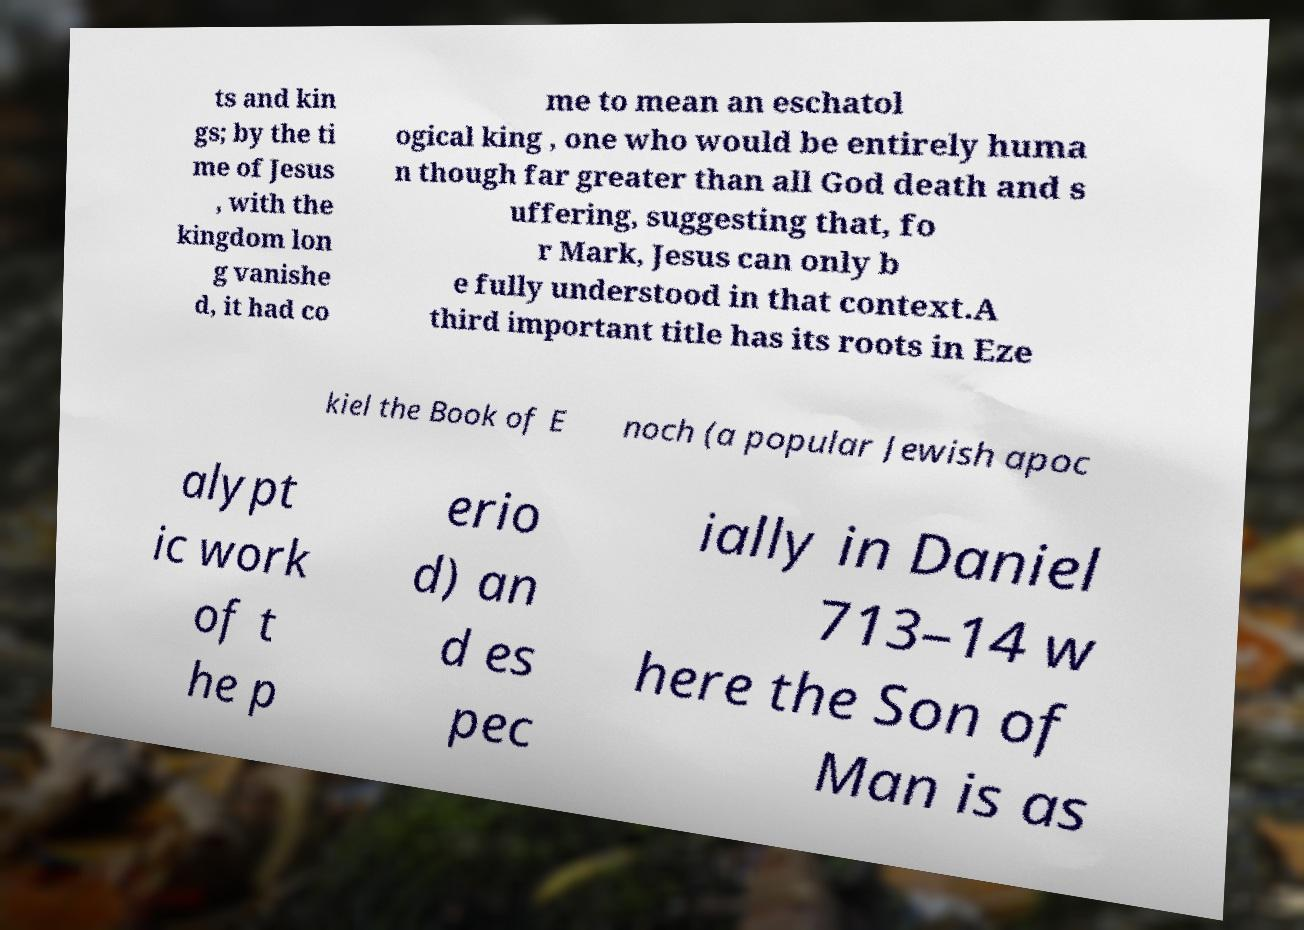Can you accurately transcribe the text from the provided image for me? ts and kin gs; by the ti me of Jesus , with the kingdom lon g vanishe d, it had co me to mean an eschatol ogical king , one who would be entirely huma n though far greater than all God death and s uffering, suggesting that, fo r Mark, Jesus can only b e fully understood in that context.A third important title has its roots in Eze kiel the Book of E noch (a popular Jewish apoc alypt ic work of t he p erio d) an d es pec ially in Daniel 713–14 w here the Son of Man is as 